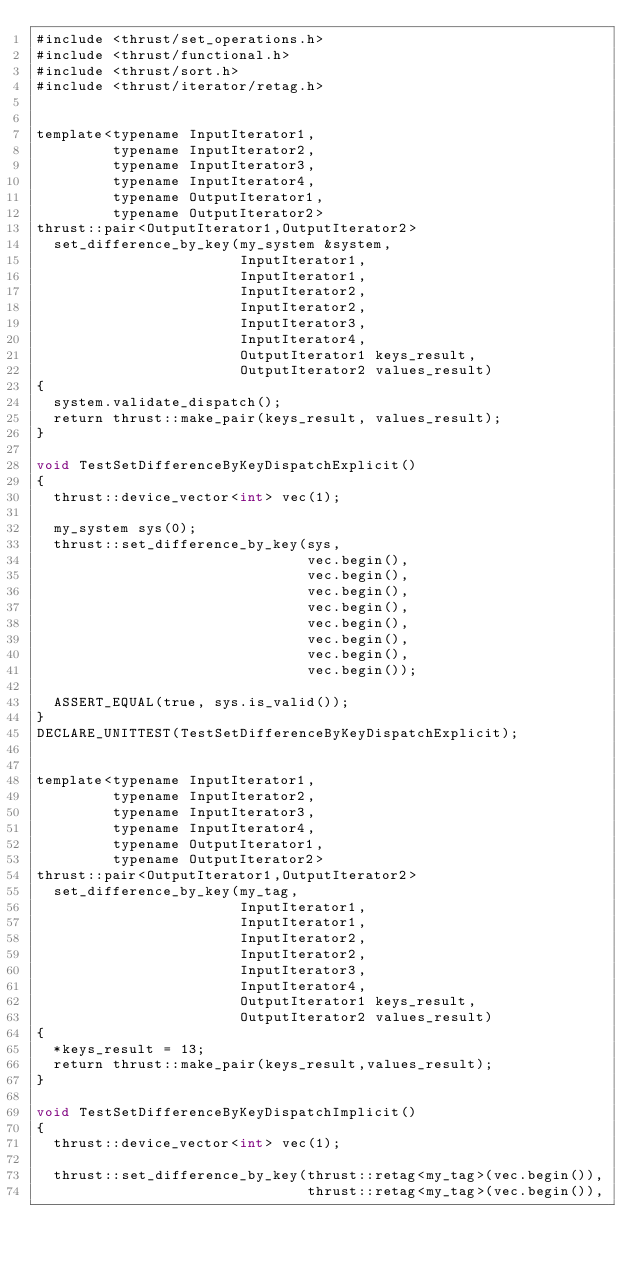Convert code to text. <code><loc_0><loc_0><loc_500><loc_500><_Cuda_>#include <thrust/set_operations.h>
#include <thrust/functional.h>
#include <thrust/sort.h>
#include <thrust/iterator/retag.h>


template<typename InputIterator1,
         typename InputIterator2,
         typename InputIterator3,
         typename InputIterator4,
         typename OutputIterator1,
         typename OutputIterator2>
thrust::pair<OutputIterator1,OutputIterator2>
  set_difference_by_key(my_system &system,
                        InputIterator1,
                        InputIterator1,
                        InputIterator2,
                        InputIterator2,
                        InputIterator3,
                        InputIterator4,
                        OutputIterator1 keys_result,
                        OutputIterator2 values_result)
{
  system.validate_dispatch();
  return thrust::make_pair(keys_result, values_result);
}

void TestSetDifferenceByKeyDispatchExplicit()
{
  thrust::device_vector<int> vec(1);

  my_system sys(0);
  thrust::set_difference_by_key(sys,
                                vec.begin(),
                                vec.begin(),
                                vec.begin(),
                                vec.begin(),
                                vec.begin(),
                                vec.begin(),
                                vec.begin(),
                                vec.begin());

  ASSERT_EQUAL(true, sys.is_valid());
}
DECLARE_UNITTEST(TestSetDifferenceByKeyDispatchExplicit);


template<typename InputIterator1,
         typename InputIterator2,
         typename InputIterator3,
         typename InputIterator4,
         typename OutputIterator1,
         typename OutputIterator2>
thrust::pair<OutputIterator1,OutputIterator2>
  set_difference_by_key(my_tag,
                        InputIterator1,
                        InputIterator1,
                        InputIterator2,
                        InputIterator2,
                        InputIterator3,
                        InputIterator4,
                        OutputIterator1 keys_result,
                        OutputIterator2 values_result)
{
  *keys_result = 13;
  return thrust::make_pair(keys_result,values_result);
}

void TestSetDifferenceByKeyDispatchImplicit()
{
  thrust::device_vector<int> vec(1);

  thrust::set_difference_by_key(thrust::retag<my_tag>(vec.begin()),
                                thrust::retag<my_tag>(vec.begin()),</code> 